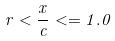<formula> <loc_0><loc_0><loc_500><loc_500>r < \frac { x } { c } < = 1 . 0</formula> 